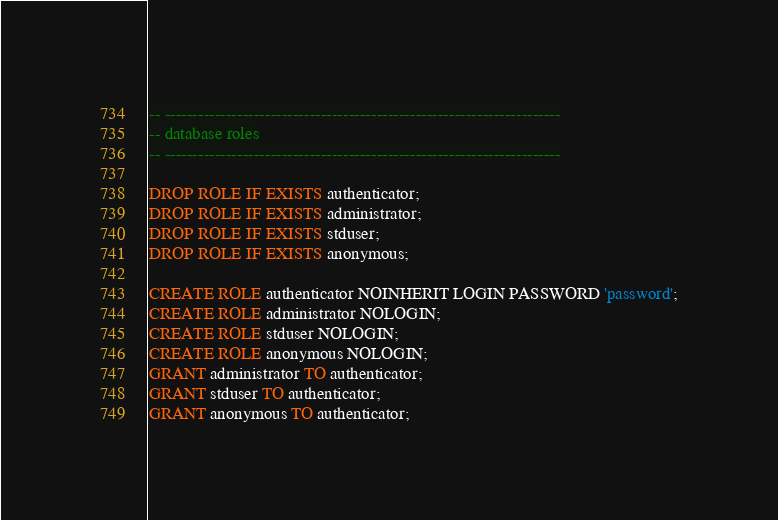Convert code to text. <code><loc_0><loc_0><loc_500><loc_500><_SQL_>-- -----------------------------------------------------------------------
-- database roles
-- -----------------------------------------------------------------------

DROP ROLE IF EXISTS authenticator;
DROP ROLE IF EXISTS administrator;
DROP ROLE IF EXISTS stduser;
DROP ROLE IF EXISTS anonymous;

CREATE ROLE authenticator NOINHERIT LOGIN PASSWORD 'password';
CREATE ROLE administrator NOLOGIN;
CREATE ROLE stduser NOLOGIN;
CREATE ROLE anonymous NOLOGIN;
GRANT administrator TO authenticator;
GRANT stduser TO authenticator;
GRANT anonymous TO authenticator;
</code> 